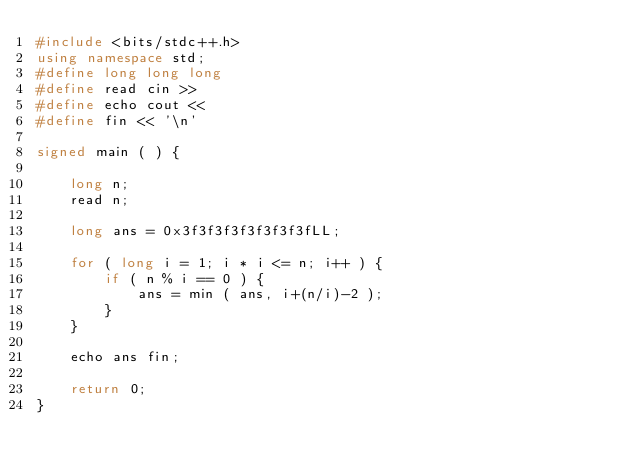Convert code to text. <code><loc_0><loc_0><loc_500><loc_500><_C++_>#include <bits/stdc++.h>
using namespace std;
#define long long long
#define read cin >>
#define echo cout <<
#define fin << '\n'

signed main ( ) {

    long n;
    read n;

    long ans = 0x3f3f3f3f3f3f3f3fLL;

    for ( long i = 1; i * i <= n; i++ ) {
        if ( n % i == 0 ) {
            ans = min ( ans, i+(n/i)-2 );
        }
    }

    echo ans fin;

    return 0;
}</code> 